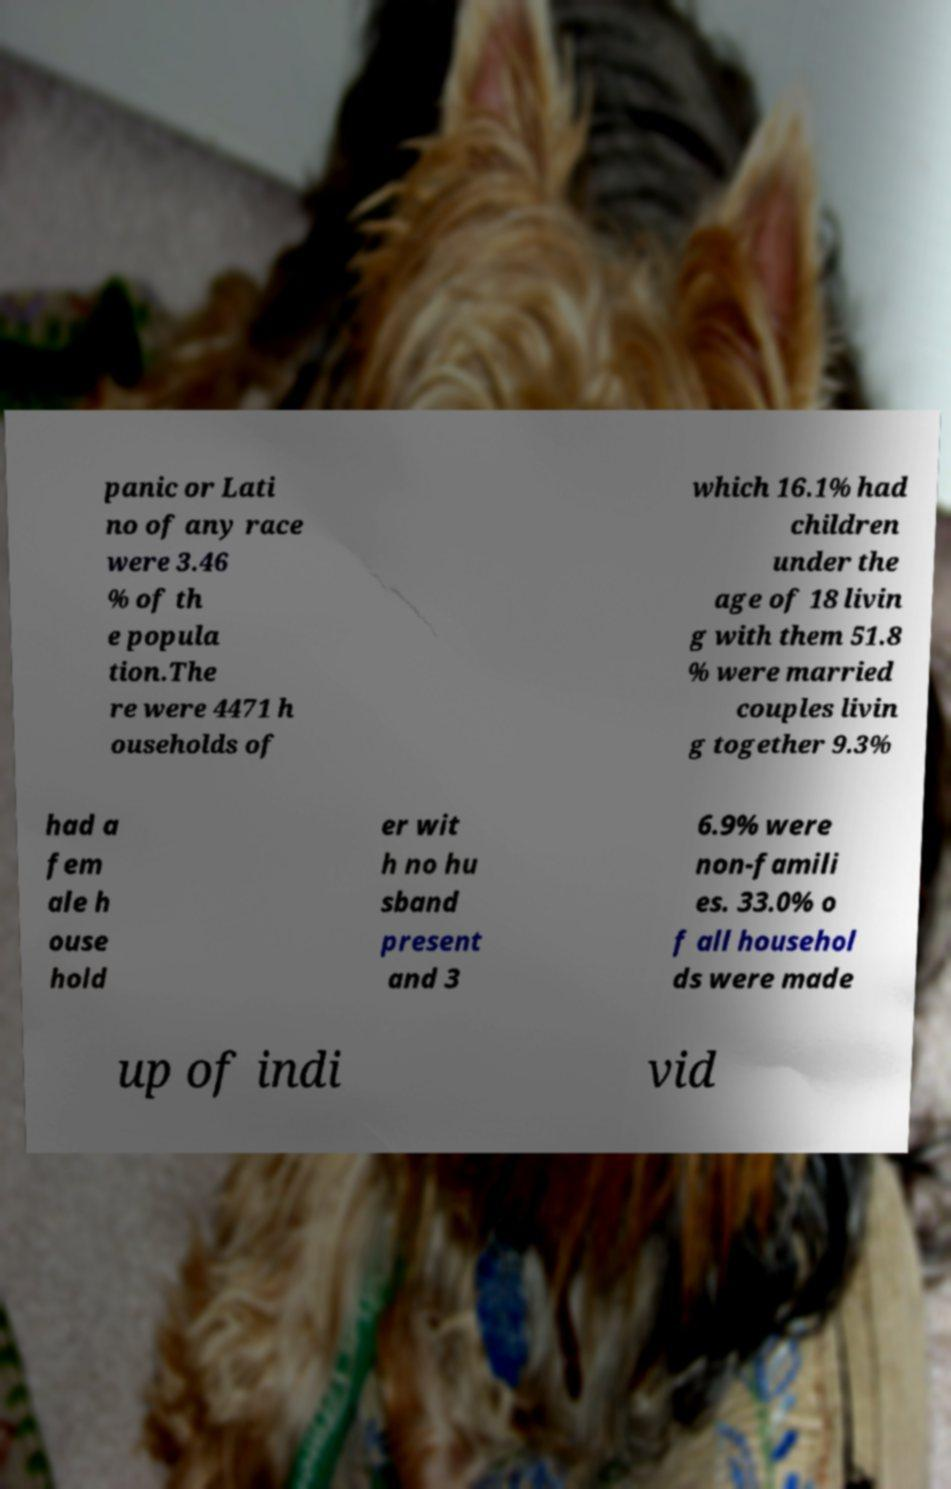For documentation purposes, I need the text within this image transcribed. Could you provide that? panic or Lati no of any race were 3.46 % of th e popula tion.The re were 4471 h ouseholds of which 16.1% had children under the age of 18 livin g with them 51.8 % were married couples livin g together 9.3% had a fem ale h ouse hold er wit h no hu sband present and 3 6.9% were non-famili es. 33.0% o f all househol ds were made up of indi vid 